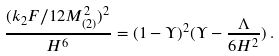<formula> <loc_0><loc_0><loc_500><loc_500>\frac { ( k _ { 2 } F / 1 2 M ^ { 2 } _ { ( 2 ) } ) ^ { 2 } } { H ^ { 6 } } = ( 1 - \Upsilon ) ^ { 2 } ( \Upsilon - \frac { \Lambda } { 6 H ^ { 2 } } ) \, .</formula> 